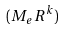<formula> <loc_0><loc_0><loc_500><loc_500>( M _ { e } R ^ { k } )</formula> 